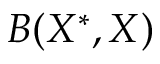<formula> <loc_0><loc_0><loc_500><loc_500>B ( X ^ { \ast } , X )</formula> 